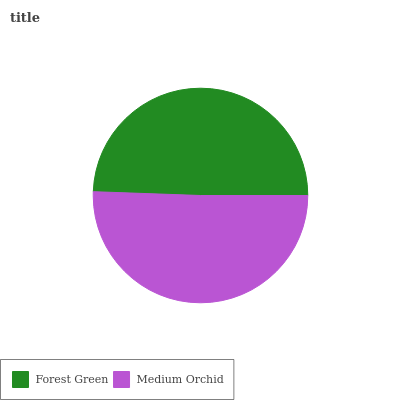Is Forest Green the minimum?
Answer yes or no. Yes. Is Medium Orchid the maximum?
Answer yes or no. Yes. Is Medium Orchid the minimum?
Answer yes or no. No. Is Medium Orchid greater than Forest Green?
Answer yes or no. Yes. Is Forest Green less than Medium Orchid?
Answer yes or no. Yes. Is Forest Green greater than Medium Orchid?
Answer yes or no. No. Is Medium Orchid less than Forest Green?
Answer yes or no. No. Is Medium Orchid the high median?
Answer yes or no. Yes. Is Forest Green the low median?
Answer yes or no. Yes. Is Forest Green the high median?
Answer yes or no. No. Is Medium Orchid the low median?
Answer yes or no. No. 